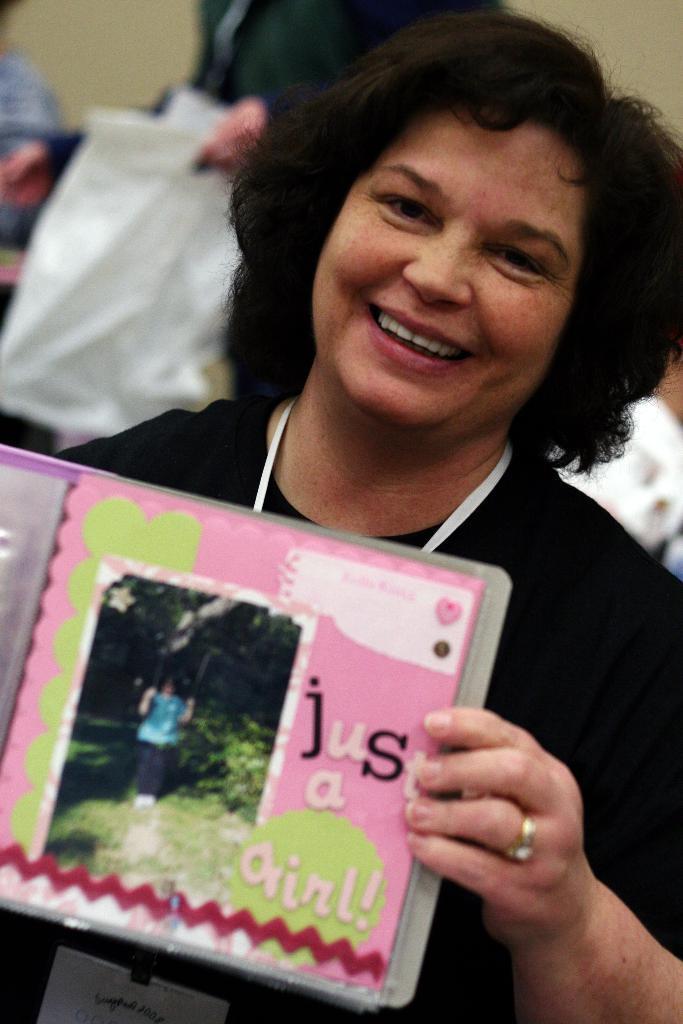Please provide a concise description of this image. In the middle of the image a woman is standing and holding a book and she is smiling. Behind her few people are standing and holding some papers. 